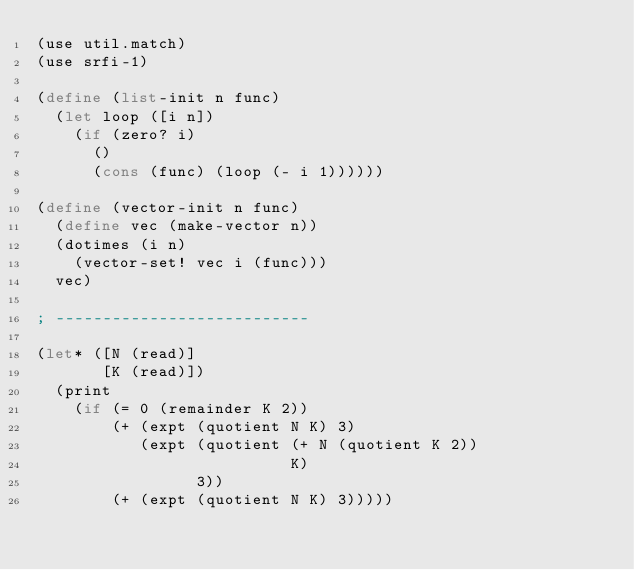Convert code to text. <code><loc_0><loc_0><loc_500><loc_500><_Scheme_>(use util.match)
(use srfi-1)

(define (list-init n func)
  (let loop ([i n])
    (if (zero? i)
      ()
      (cons (func) (loop (- i 1))))))

(define (vector-init n func)
  (define vec (make-vector n))
  (dotimes (i n)
    (vector-set! vec i (func)))
  vec)

; ---------------------------

(let* ([N (read)]
       [K (read)])
  (print
    (if (= 0 (remainder K 2))
        (+ (expt (quotient N K) 3) 
           (expt (quotient (+ N (quotient K 2))
                           K)
                 3))
        (+ (expt (quotient N K) 3)))))</code> 